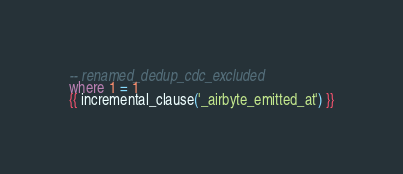<code> <loc_0><loc_0><loc_500><loc_500><_SQL_>-- renamed_dedup_cdc_excluded
where 1 = 1
{{ incremental_clause('_airbyte_emitted_at') }}

</code> 